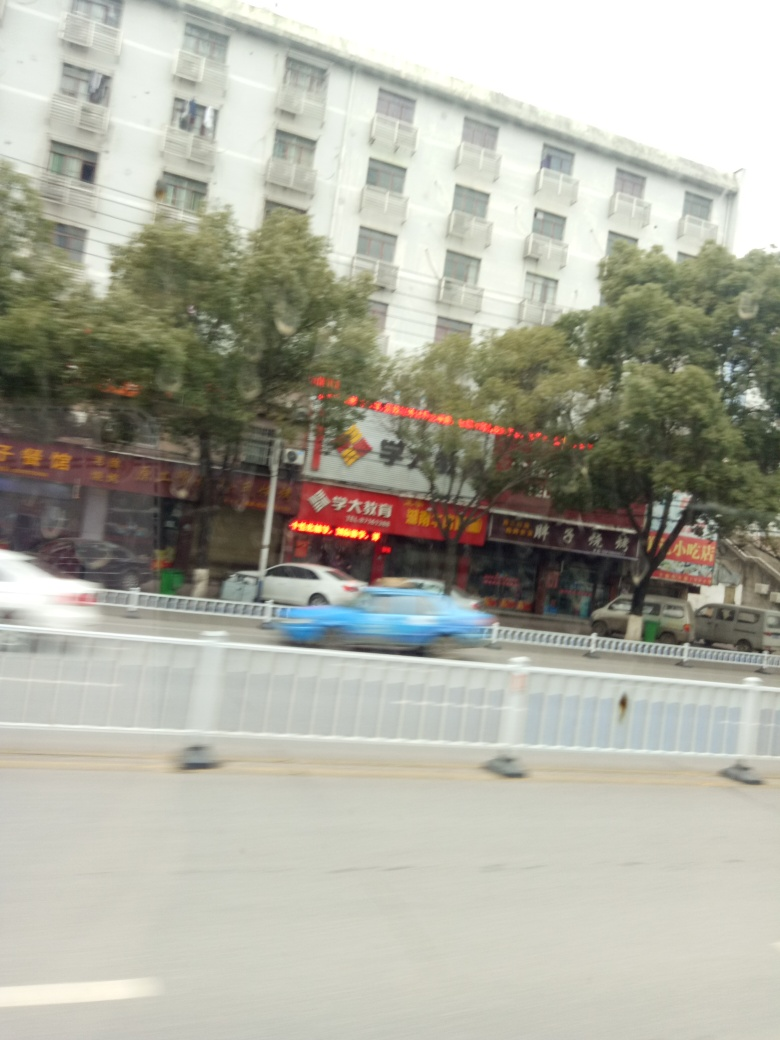What kind of setting is this image depicting? The image depicts an urban setting, with apartment buildings, a line of shops with bright signage, and a bustling street visible. The presence of vehicles suggests this is a moderately busy area with commercial activity. 